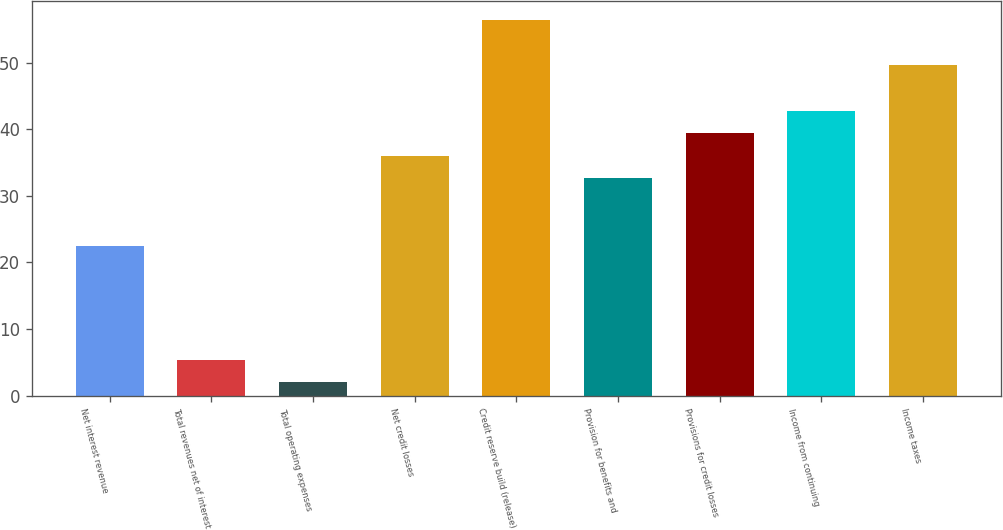Convert chart to OTSL. <chart><loc_0><loc_0><loc_500><loc_500><bar_chart><fcel>Net interest revenue<fcel>Total revenues net of interest<fcel>Total operating expenses<fcel>Net credit losses<fcel>Credit reserve build (release)<fcel>Provision for benefits and<fcel>Provisions for credit losses<fcel>Income from continuing<fcel>Income taxes<nl><fcel>22.4<fcel>5.4<fcel>2<fcel>36<fcel>56.4<fcel>32.6<fcel>39.4<fcel>42.8<fcel>49.6<nl></chart> 